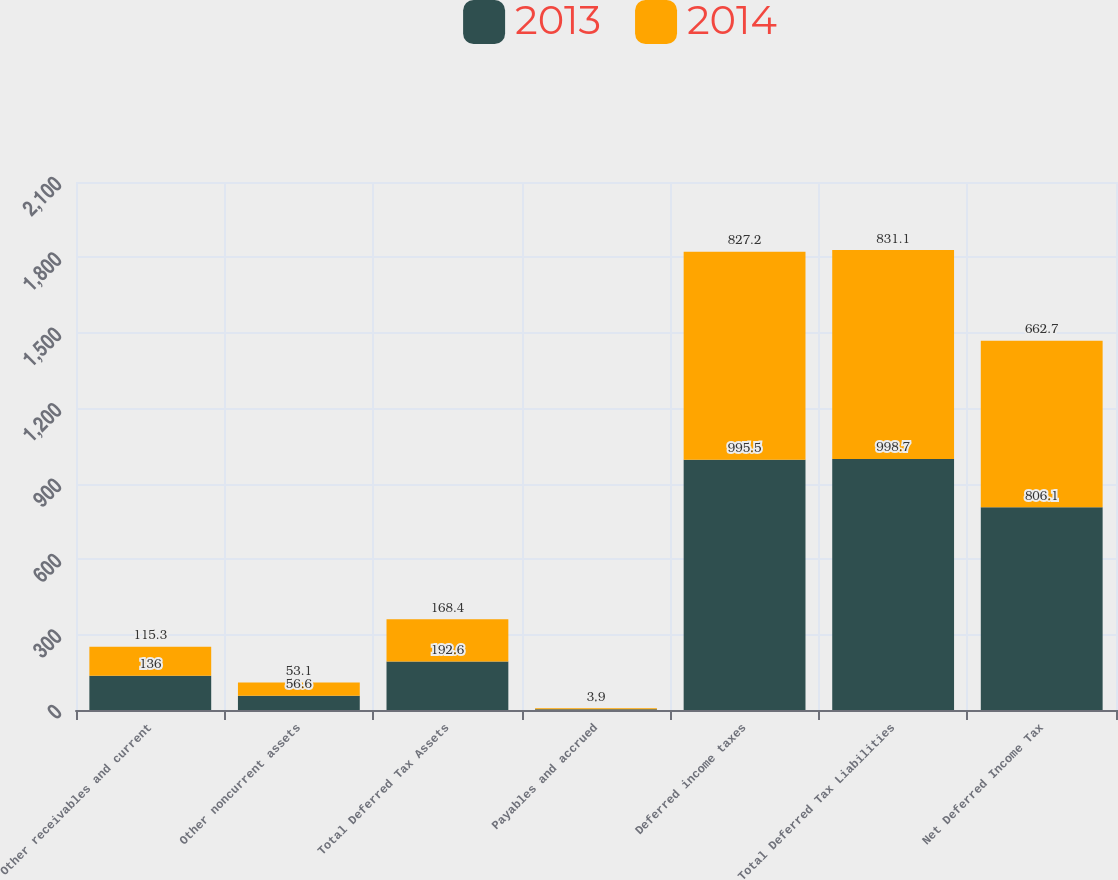Convert chart to OTSL. <chart><loc_0><loc_0><loc_500><loc_500><stacked_bar_chart><ecel><fcel>Other receivables and current<fcel>Other noncurrent assets<fcel>Total Deferred Tax Assets<fcel>Payables and accrued<fcel>Deferred income taxes<fcel>Total Deferred Tax Liabilities<fcel>Net Deferred Income Tax<nl><fcel>2013<fcel>136<fcel>56.6<fcel>192.6<fcel>3.2<fcel>995.5<fcel>998.7<fcel>806.1<nl><fcel>2014<fcel>115.3<fcel>53.1<fcel>168.4<fcel>3.9<fcel>827.2<fcel>831.1<fcel>662.7<nl></chart> 